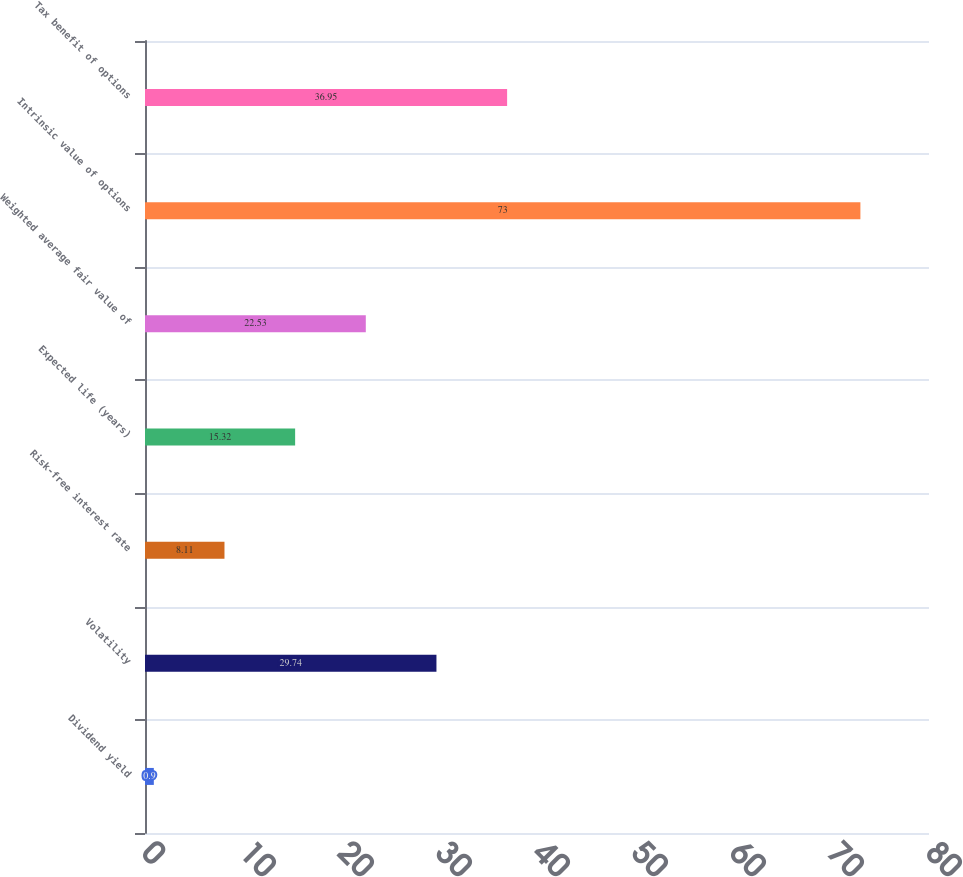<chart> <loc_0><loc_0><loc_500><loc_500><bar_chart><fcel>Dividend yield<fcel>Volatility<fcel>Risk-free interest rate<fcel>Expected life (years)<fcel>Weighted average fair value of<fcel>Intrinsic value of options<fcel>Tax benefit of options<nl><fcel>0.9<fcel>29.74<fcel>8.11<fcel>15.32<fcel>22.53<fcel>73<fcel>36.95<nl></chart> 